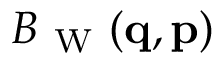Convert formula to latex. <formula><loc_0><loc_0><loc_500><loc_500>B _ { W } ( { q } , { p } )</formula> 